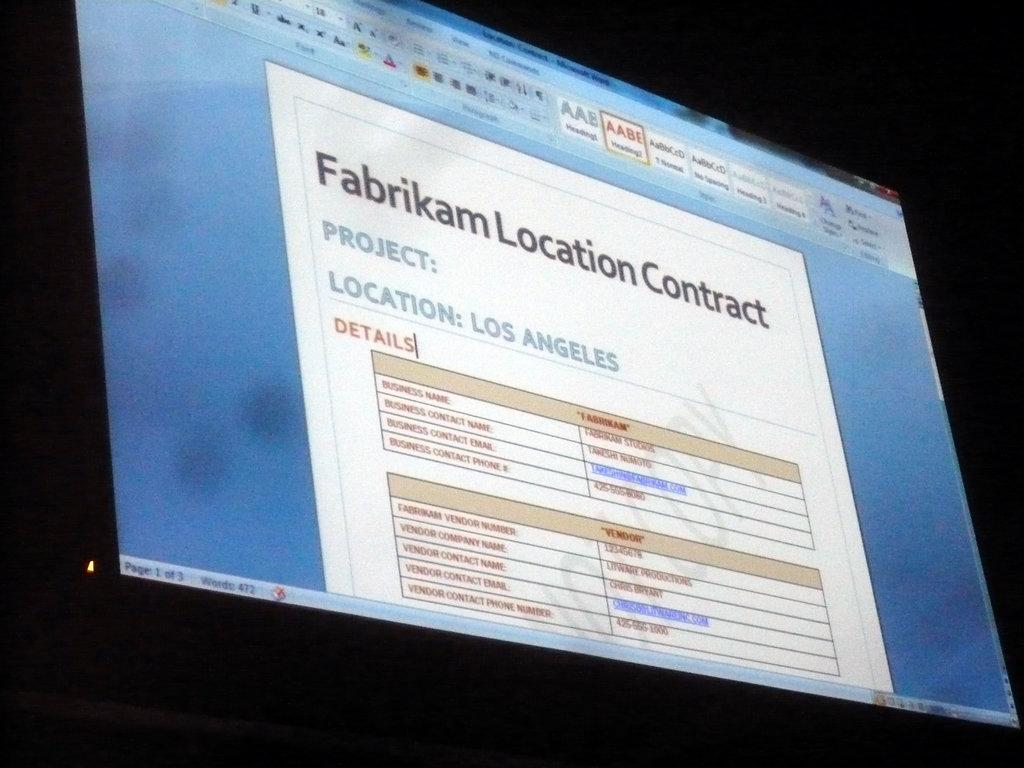What is the main object in the image? There is a screen in the image. What can be seen on the screen? The screen displays some information. How would you describe the overall appearance of the image? The background of the image is dark. What type of cabbage is being thrown away in the image? There is no cabbage or waste present in the image; it only features a screen displaying information with a dark background. 